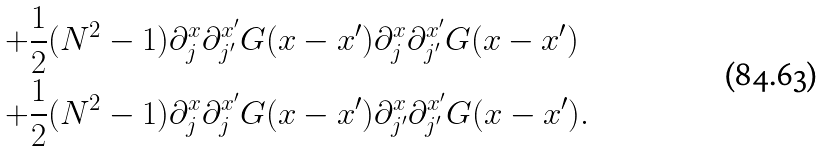<formula> <loc_0><loc_0><loc_500><loc_500>+ \frac { 1 } { 2 } & ( N ^ { 2 } - 1 ) \partial _ { j } ^ { x } \partial _ { j ^ { \prime } } ^ { x ^ { \prime } } G ( x - x ^ { \prime } ) \partial _ { j } ^ { x } \partial _ { j ^ { \prime } } ^ { x ^ { \prime } } G ( x - x ^ { \prime } ) \\ + \frac { 1 } { 2 } & ( N ^ { 2 } - 1 ) \partial _ { j } ^ { x } \partial _ { j } ^ { x ^ { \prime } } G ( x - x ^ { \prime } ) \partial _ { j ^ { \prime } } ^ { x } \partial _ { j ^ { \prime } } ^ { x ^ { \prime } } G ( x - x ^ { \prime } ) .</formula> 